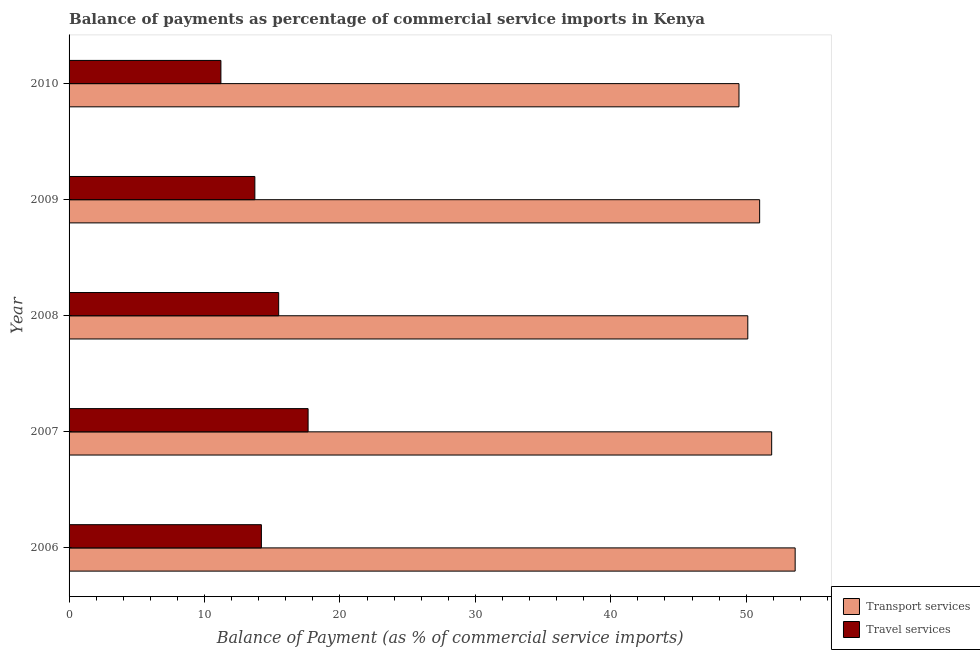How many different coloured bars are there?
Offer a very short reply. 2. How many groups of bars are there?
Your answer should be very brief. 5. Are the number of bars on each tick of the Y-axis equal?
Make the answer very short. Yes. How many bars are there on the 5th tick from the bottom?
Provide a short and direct response. 2. What is the label of the 2nd group of bars from the top?
Offer a very short reply. 2009. In how many cases, is the number of bars for a given year not equal to the number of legend labels?
Provide a succinct answer. 0. What is the balance of payments of transport services in 2008?
Make the answer very short. 50.12. Across all years, what is the maximum balance of payments of travel services?
Offer a terse response. 17.65. Across all years, what is the minimum balance of payments of travel services?
Make the answer very short. 11.21. In which year was the balance of payments of travel services minimum?
Make the answer very short. 2010. What is the total balance of payments of travel services in the graph?
Provide a short and direct response. 72.26. What is the difference between the balance of payments of travel services in 2007 and that in 2009?
Keep it short and to the point. 3.93. What is the difference between the balance of payments of transport services in 2006 and the balance of payments of travel services in 2007?
Your response must be concise. 35.96. What is the average balance of payments of transport services per year?
Offer a very short reply. 51.21. In the year 2007, what is the difference between the balance of payments of transport services and balance of payments of travel services?
Ensure brevity in your answer.  34.23. What is the ratio of the balance of payments of travel services in 2006 to that in 2008?
Your answer should be compact. 0.92. What is the difference between the highest and the second highest balance of payments of travel services?
Offer a very short reply. 2.17. What is the difference between the highest and the lowest balance of payments of travel services?
Give a very brief answer. 6.44. In how many years, is the balance of payments of travel services greater than the average balance of payments of travel services taken over all years?
Your response must be concise. 2. Is the sum of the balance of payments of transport services in 2006 and 2007 greater than the maximum balance of payments of travel services across all years?
Offer a terse response. Yes. What does the 1st bar from the top in 2008 represents?
Provide a short and direct response. Travel services. What does the 1st bar from the bottom in 2006 represents?
Your answer should be compact. Transport services. How many bars are there?
Provide a short and direct response. 10. Are all the bars in the graph horizontal?
Give a very brief answer. Yes. Where does the legend appear in the graph?
Make the answer very short. Bottom right. How many legend labels are there?
Your answer should be very brief. 2. What is the title of the graph?
Your response must be concise. Balance of payments as percentage of commercial service imports in Kenya. Does "Registered firms" appear as one of the legend labels in the graph?
Your answer should be very brief. No. What is the label or title of the X-axis?
Make the answer very short. Balance of Payment (as % of commercial service imports). What is the Balance of Payment (as % of commercial service imports) in Transport services in 2006?
Ensure brevity in your answer.  53.61. What is the Balance of Payment (as % of commercial service imports) of Travel services in 2006?
Keep it short and to the point. 14.2. What is the Balance of Payment (as % of commercial service imports) of Transport services in 2007?
Keep it short and to the point. 51.88. What is the Balance of Payment (as % of commercial service imports) of Travel services in 2007?
Make the answer very short. 17.65. What is the Balance of Payment (as % of commercial service imports) in Transport services in 2008?
Provide a short and direct response. 50.12. What is the Balance of Payment (as % of commercial service imports) in Travel services in 2008?
Your answer should be very brief. 15.48. What is the Balance of Payment (as % of commercial service imports) in Transport services in 2009?
Keep it short and to the point. 50.99. What is the Balance of Payment (as % of commercial service imports) of Travel services in 2009?
Ensure brevity in your answer.  13.72. What is the Balance of Payment (as % of commercial service imports) of Transport services in 2010?
Give a very brief answer. 49.47. What is the Balance of Payment (as % of commercial service imports) of Travel services in 2010?
Provide a succinct answer. 11.21. Across all years, what is the maximum Balance of Payment (as % of commercial service imports) in Transport services?
Provide a succinct answer. 53.61. Across all years, what is the maximum Balance of Payment (as % of commercial service imports) of Travel services?
Your answer should be very brief. 17.65. Across all years, what is the minimum Balance of Payment (as % of commercial service imports) of Transport services?
Make the answer very short. 49.47. Across all years, what is the minimum Balance of Payment (as % of commercial service imports) of Travel services?
Your response must be concise. 11.21. What is the total Balance of Payment (as % of commercial service imports) of Transport services in the graph?
Your response must be concise. 256.07. What is the total Balance of Payment (as % of commercial service imports) in Travel services in the graph?
Your response must be concise. 72.26. What is the difference between the Balance of Payment (as % of commercial service imports) in Transport services in 2006 and that in 2007?
Make the answer very short. 1.73. What is the difference between the Balance of Payment (as % of commercial service imports) of Travel services in 2006 and that in 2007?
Ensure brevity in your answer.  -3.45. What is the difference between the Balance of Payment (as % of commercial service imports) of Transport services in 2006 and that in 2008?
Offer a terse response. 3.5. What is the difference between the Balance of Payment (as % of commercial service imports) of Travel services in 2006 and that in 2008?
Your response must be concise. -1.28. What is the difference between the Balance of Payment (as % of commercial service imports) in Transport services in 2006 and that in 2009?
Provide a succinct answer. 2.62. What is the difference between the Balance of Payment (as % of commercial service imports) in Travel services in 2006 and that in 2009?
Give a very brief answer. 0.48. What is the difference between the Balance of Payment (as % of commercial service imports) in Transport services in 2006 and that in 2010?
Provide a short and direct response. 4.15. What is the difference between the Balance of Payment (as % of commercial service imports) of Travel services in 2006 and that in 2010?
Offer a very short reply. 2.99. What is the difference between the Balance of Payment (as % of commercial service imports) of Transport services in 2007 and that in 2008?
Provide a short and direct response. 1.76. What is the difference between the Balance of Payment (as % of commercial service imports) in Travel services in 2007 and that in 2008?
Provide a succinct answer. 2.17. What is the difference between the Balance of Payment (as % of commercial service imports) in Transport services in 2007 and that in 2009?
Provide a succinct answer. 0.89. What is the difference between the Balance of Payment (as % of commercial service imports) in Travel services in 2007 and that in 2009?
Make the answer very short. 3.93. What is the difference between the Balance of Payment (as % of commercial service imports) of Transport services in 2007 and that in 2010?
Offer a terse response. 2.41. What is the difference between the Balance of Payment (as % of commercial service imports) of Travel services in 2007 and that in 2010?
Offer a terse response. 6.44. What is the difference between the Balance of Payment (as % of commercial service imports) of Transport services in 2008 and that in 2009?
Ensure brevity in your answer.  -0.87. What is the difference between the Balance of Payment (as % of commercial service imports) in Travel services in 2008 and that in 2009?
Offer a terse response. 1.76. What is the difference between the Balance of Payment (as % of commercial service imports) in Transport services in 2008 and that in 2010?
Ensure brevity in your answer.  0.65. What is the difference between the Balance of Payment (as % of commercial service imports) in Travel services in 2008 and that in 2010?
Your answer should be compact. 4.27. What is the difference between the Balance of Payment (as % of commercial service imports) of Transport services in 2009 and that in 2010?
Give a very brief answer. 1.53. What is the difference between the Balance of Payment (as % of commercial service imports) of Travel services in 2009 and that in 2010?
Your response must be concise. 2.51. What is the difference between the Balance of Payment (as % of commercial service imports) in Transport services in 2006 and the Balance of Payment (as % of commercial service imports) in Travel services in 2007?
Your response must be concise. 35.96. What is the difference between the Balance of Payment (as % of commercial service imports) in Transport services in 2006 and the Balance of Payment (as % of commercial service imports) in Travel services in 2008?
Provide a succinct answer. 38.14. What is the difference between the Balance of Payment (as % of commercial service imports) in Transport services in 2006 and the Balance of Payment (as % of commercial service imports) in Travel services in 2009?
Your response must be concise. 39.9. What is the difference between the Balance of Payment (as % of commercial service imports) of Transport services in 2006 and the Balance of Payment (as % of commercial service imports) of Travel services in 2010?
Offer a terse response. 42.4. What is the difference between the Balance of Payment (as % of commercial service imports) of Transport services in 2007 and the Balance of Payment (as % of commercial service imports) of Travel services in 2008?
Make the answer very short. 36.4. What is the difference between the Balance of Payment (as % of commercial service imports) of Transport services in 2007 and the Balance of Payment (as % of commercial service imports) of Travel services in 2009?
Give a very brief answer. 38.16. What is the difference between the Balance of Payment (as % of commercial service imports) in Transport services in 2007 and the Balance of Payment (as % of commercial service imports) in Travel services in 2010?
Keep it short and to the point. 40.67. What is the difference between the Balance of Payment (as % of commercial service imports) in Transport services in 2008 and the Balance of Payment (as % of commercial service imports) in Travel services in 2009?
Your answer should be very brief. 36.4. What is the difference between the Balance of Payment (as % of commercial service imports) in Transport services in 2008 and the Balance of Payment (as % of commercial service imports) in Travel services in 2010?
Provide a short and direct response. 38.91. What is the difference between the Balance of Payment (as % of commercial service imports) of Transport services in 2009 and the Balance of Payment (as % of commercial service imports) of Travel services in 2010?
Offer a very short reply. 39.78. What is the average Balance of Payment (as % of commercial service imports) in Transport services per year?
Give a very brief answer. 51.21. What is the average Balance of Payment (as % of commercial service imports) in Travel services per year?
Make the answer very short. 14.45. In the year 2006, what is the difference between the Balance of Payment (as % of commercial service imports) of Transport services and Balance of Payment (as % of commercial service imports) of Travel services?
Your answer should be very brief. 39.41. In the year 2007, what is the difference between the Balance of Payment (as % of commercial service imports) in Transport services and Balance of Payment (as % of commercial service imports) in Travel services?
Keep it short and to the point. 34.23. In the year 2008, what is the difference between the Balance of Payment (as % of commercial service imports) of Transport services and Balance of Payment (as % of commercial service imports) of Travel services?
Your response must be concise. 34.64. In the year 2009, what is the difference between the Balance of Payment (as % of commercial service imports) of Transport services and Balance of Payment (as % of commercial service imports) of Travel services?
Make the answer very short. 37.27. In the year 2010, what is the difference between the Balance of Payment (as % of commercial service imports) in Transport services and Balance of Payment (as % of commercial service imports) in Travel services?
Provide a succinct answer. 38.26. What is the ratio of the Balance of Payment (as % of commercial service imports) of Transport services in 2006 to that in 2007?
Make the answer very short. 1.03. What is the ratio of the Balance of Payment (as % of commercial service imports) of Travel services in 2006 to that in 2007?
Give a very brief answer. 0.8. What is the ratio of the Balance of Payment (as % of commercial service imports) in Transport services in 2006 to that in 2008?
Your response must be concise. 1.07. What is the ratio of the Balance of Payment (as % of commercial service imports) of Travel services in 2006 to that in 2008?
Provide a succinct answer. 0.92. What is the ratio of the Balance of Payment (as % of commercial service imports) in Transport services in 2006 to that in 2009?
Your answer should be very brief. 1.05. What is the ratio of the Balance of Payment (as % of commercial service imports) of Travel services in 2006 to that in 2009?
Make the answer very short. 1.04. What is the ratio of the Balance of Payment (as % of commercial service imports) of Transport services in 2006 to that in 2010?
Your response must be concise. 1.08. What is the ratio of the Balance of Payment (as % of commercial service imports) in Travel services in 2006 to that in 2010?
Provide a succinct answer. 1.27. What is the ratio of the Balance of Payment (as % of commercial service imports) of Transport services in 2007 to that in 2008?
Ensure brevity in your answer.  1.04. What is the ratio of the Balance of Payment (as % of commercial service imports) of Travel services in 2007 to that in 2008?
Your answer should be compact. 1.14. What is the ratio of the Balance of Payment (as % of commercial service imports) in Transport services in 2007 to that in 2009?
Your answer should be very brief. 1.02. What is the ratio of the Balance of Payment (as % of commercial service imports) of Travel services in 2007 to that in 2009?
Offer a very short reply. 1.29. What is the ratio of the Balance of Payment (as % of commercial service imports) in Transport services in 2007 to that in 2010?
Your answer should be very brief. 1.05. What is the ratio of the Balance of Payment (as % of commercial service imports) of Travel services in 2007 to that in 2010?
Your response must be concise. 1.57. What is the ratio of the Balance of Payment (as % of commercial service imports) in Transport services in 2008 to that in 2009?
Give a very brief answer. 0.98. What is the ratio of the Balance of Payment (as % of commercial service imports) of Travel services in 2008 to that in 2009?
Provide a succinct answer. 1.13. What is the ratio of the Balance of Payment (as % of commercial service imports) in Transport services in 2008 to that in 2010?
Provide a succinct answer. 1.01. What is the ratio of the Balance of Payment (as % of commercial service imports) of Travel services in 2008 to that in 2010?
Offer a terse response. 1.38. What is the ratio of the Balance of Payment (as % of commercial service imports) of Transport services in 2009 to that in 2010?
Keep it short and to the point. 1.03. What is the ratio of the Balance of Payment (as % of commercial service imports) of Travel services in 2009 to that in 2010?
Your response must be concise. 1.22. What is the difference between the highest and the second highest Balance of Payment (as % of commercial service imports) of Transport services?
Offer a very short reply. 1.73. What is the difference between the highest and the second highest Balance of Payment (as % of commercial service imports) in Travel services?
Keep it short and to the point. 2.17. What is the difference between the highest and the lowest Balance of Payment (as % of commercial service imports) in Transport services?
Offer a very short reply. 4.15. What is the difference between the highest and the lowest Balance of Payment (as % of commercial service imports) in Travel services?
Give a very brief answer. 6.44. 